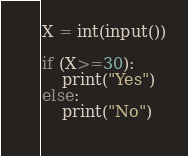Convert code to text. <code><loc_0><loc_0><loc_500><loc_500><_Python_>X = int(input())

if (X>=30):
    print("Yes")
else:
    print("No")
    
</code> 